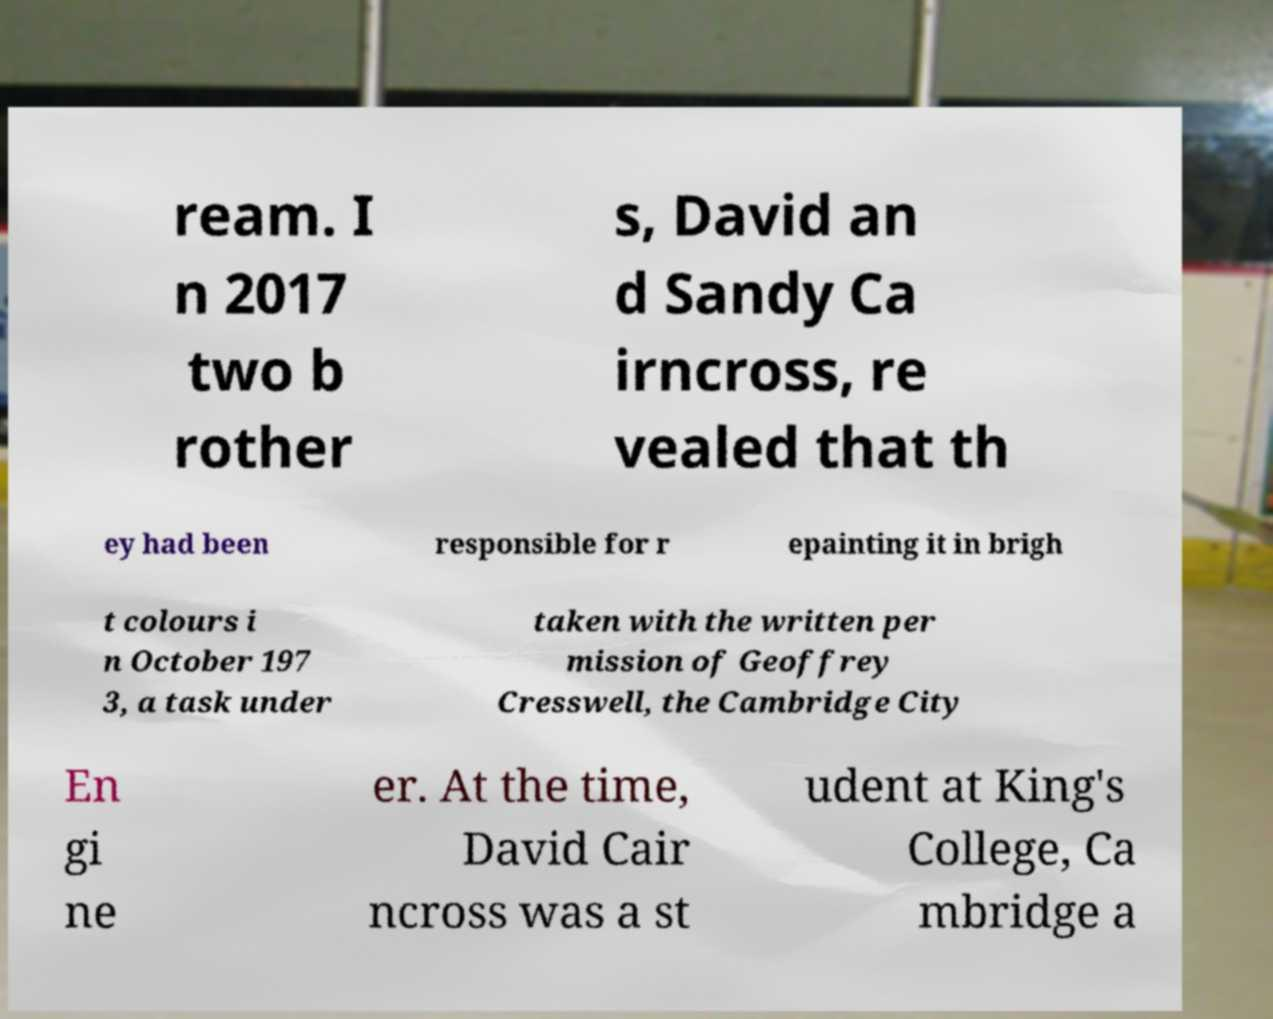Could you assist in decoding the text presented in this image and type it out clearly? ream. I n 2017 two b rother s, David an d Sandy Ca irncross, re vealed that th ey had been responsible for r epainting it in brigh t colours i n October 197 3, a task under taken with the written per mission of Geoffrey Cresswell, the Cambridge City En gi ne er. At the time, David Cair ncross was a st udent at King's College, Ca mbridge a 